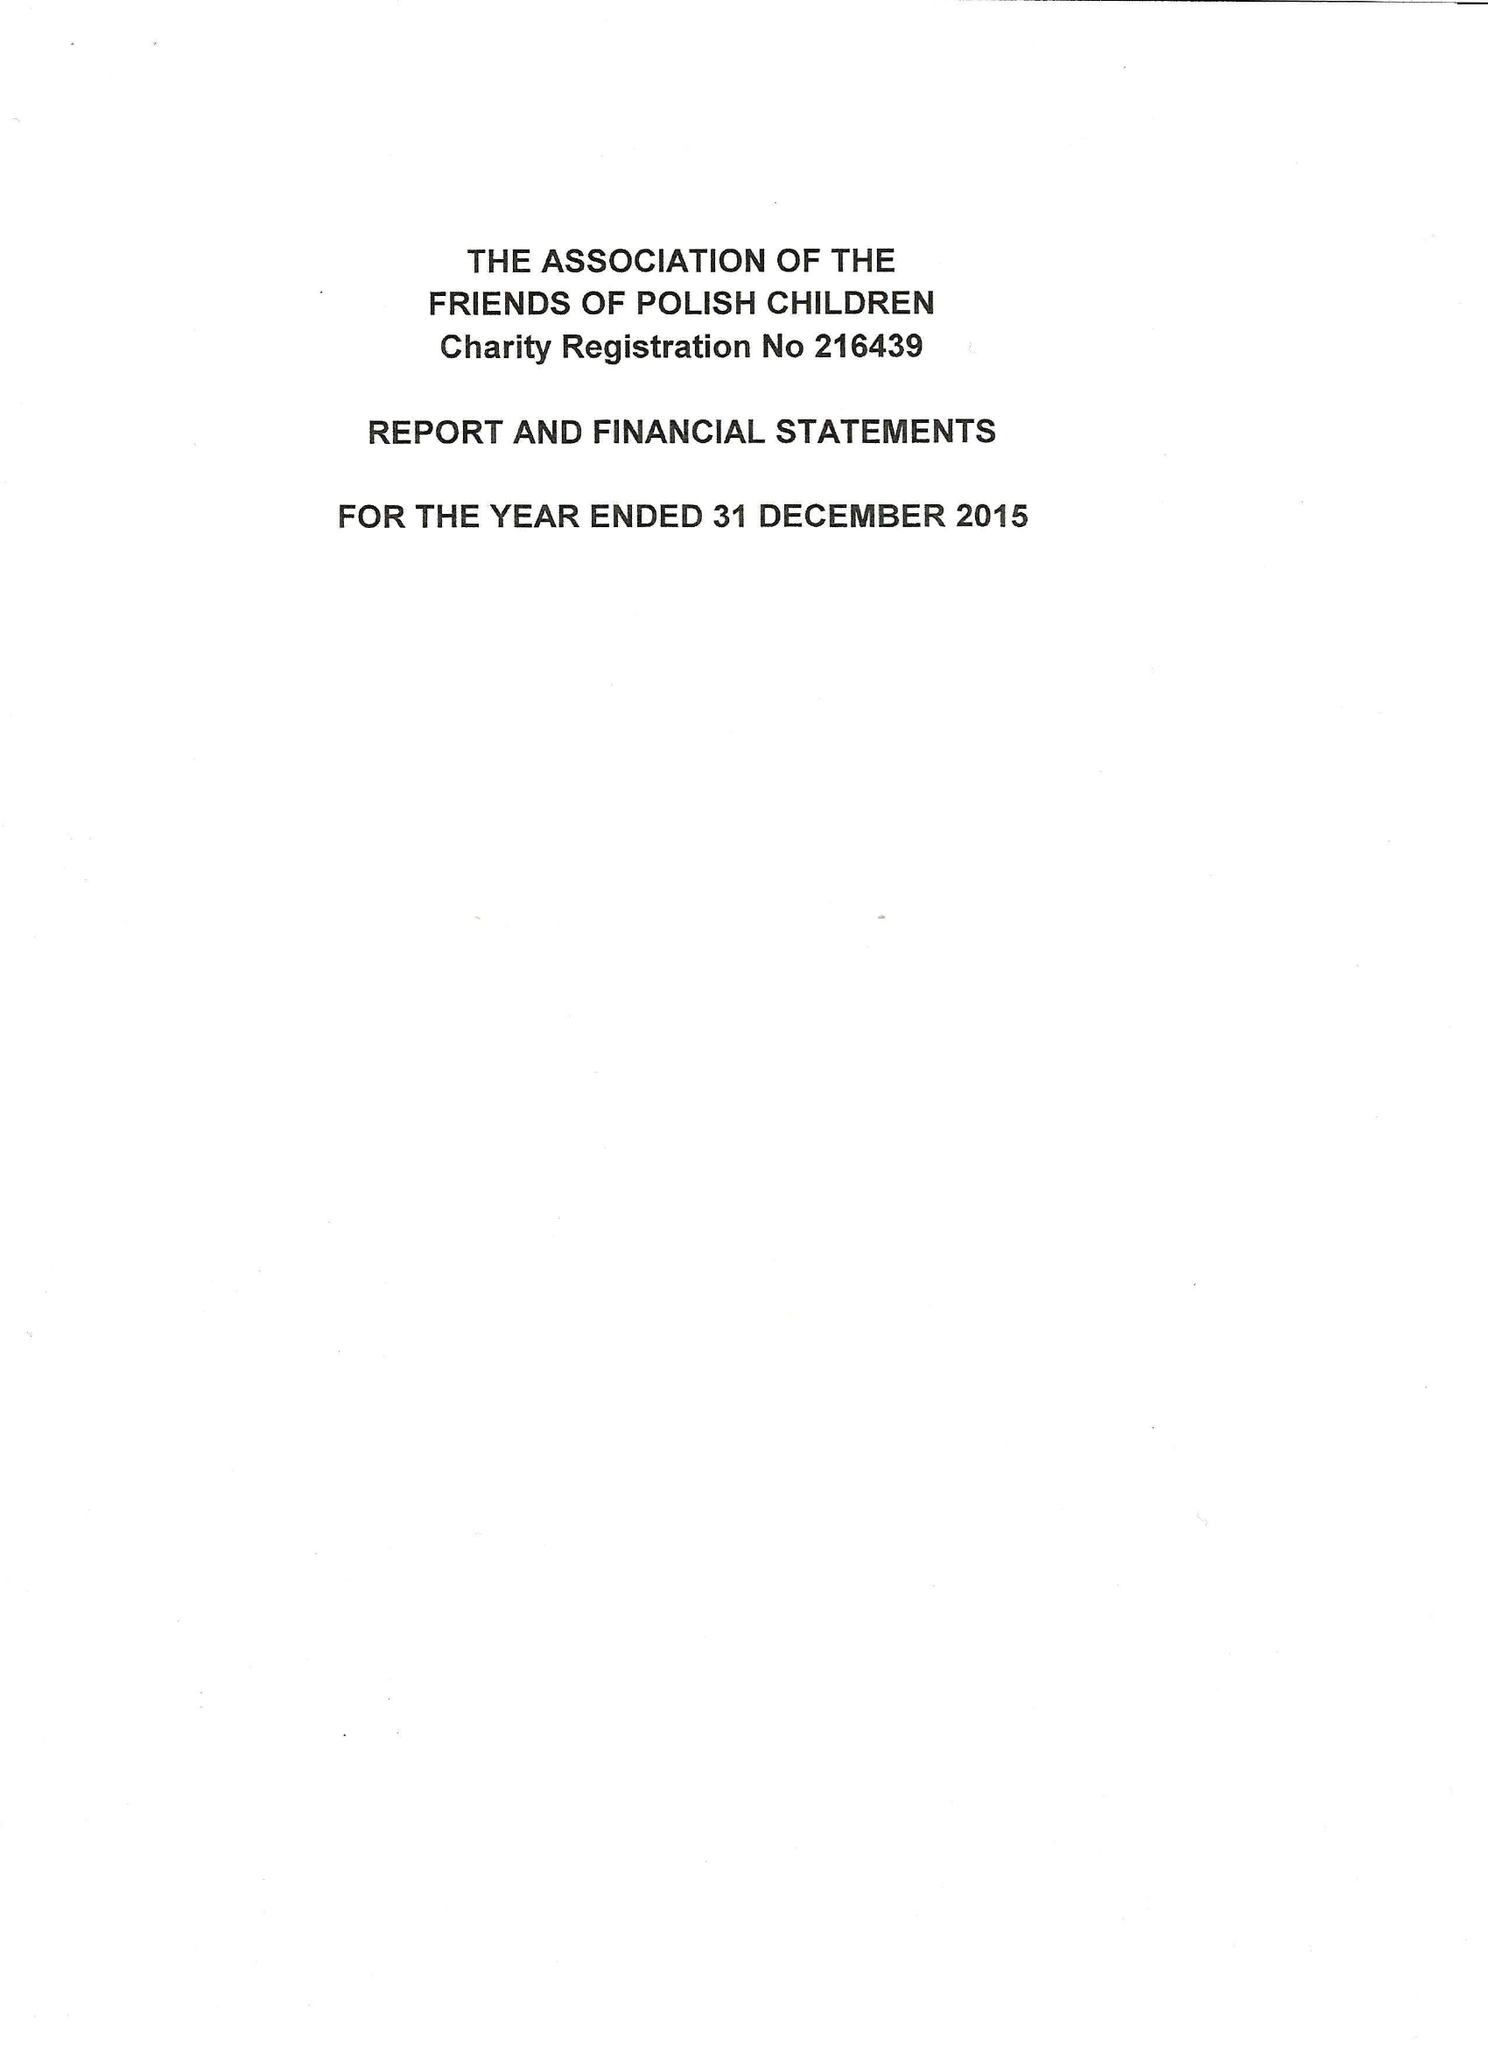What is the value for the charity_number?
Answer the question using a single word or phrase. 216439 